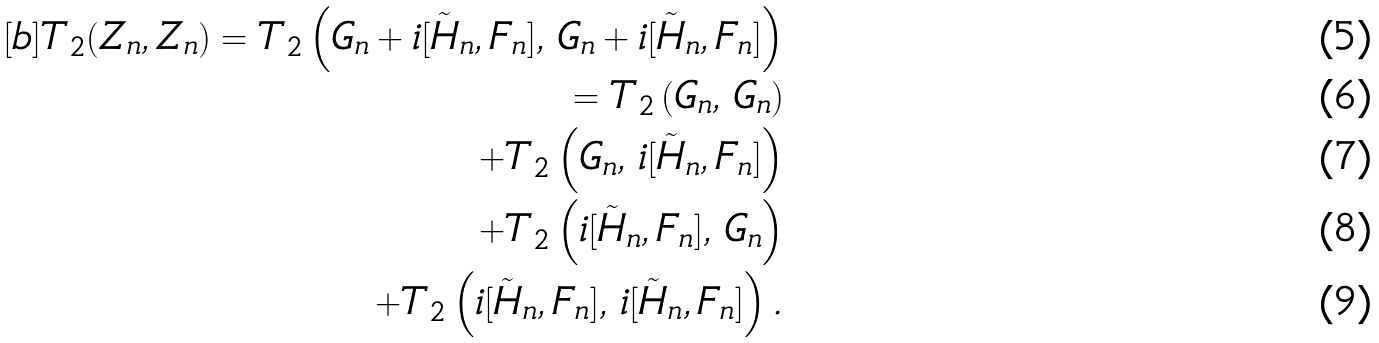Convert formula to latex. <formula><loc_0><loc_0><loc_500><loc_500>[ b ] T _ { 2 } ( Z _ { n } , Z _ { n } ) = T _ { 2 } \left ( G _ { n } + i [ \tilde { H } _ { n } , F _ { n } ] , \, G _ { n } + i [ \tilde { H } _ { n } , F _ { n } ] \right ) \\ = T _ { 2 } \left ( G _ { n } , \, G _ { n } \right ) \\ + T _ { 2 } \left ( G _ { n } , \, i [ \tilde { H } _ { n } , F _ { n } ] \right ) \\ + T _ { 2 } \left ( i [ \tilde { H } _ { n } , F _ { n } ] , \, G _ { n } \right ) \\ + T _ { 2 } \left ( i [ \tilde { H } _ { n } , F _ { n } ] , \, i [ \tilde { H } _ { n } , F _ { n } ] \right ) .</formula> 